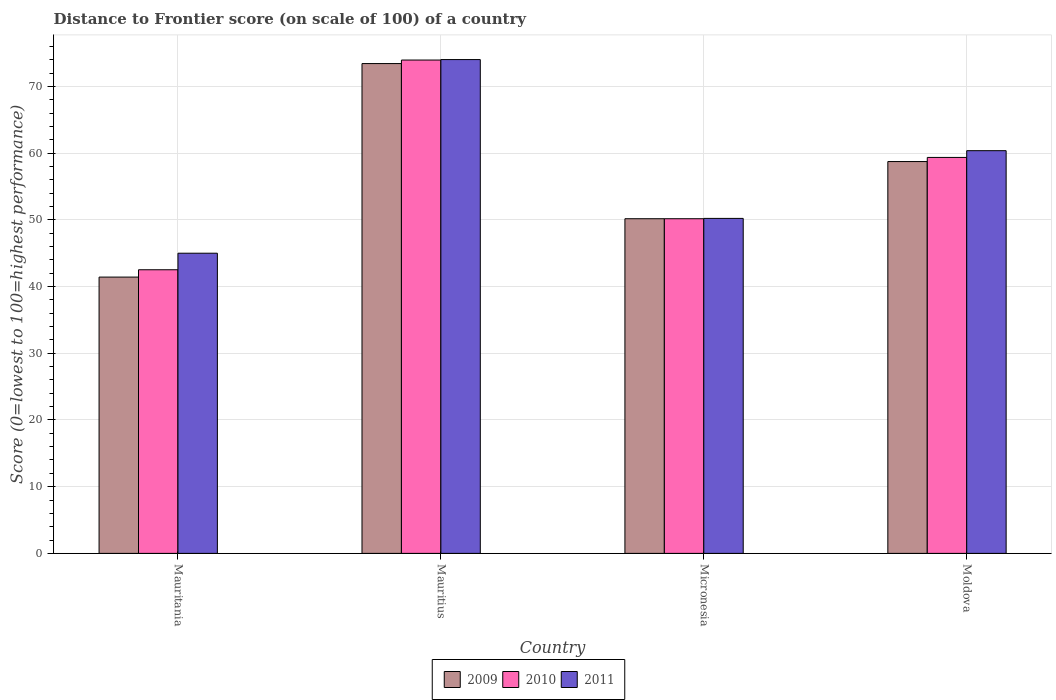How many different coloured bars are there?
Your answer should be very brief. 3. Are the number of bars per tick equal to the number of legend labels?
Give a very brief answer. Yes. Are the number of bars on each tick of the X-axis equal?
Provide a succinct answer. Yes. How many bars are there on the 3rd tick from the right?
Offer a very short reply. 3. What is the label of the 1st group of bars from the left?
Offer a terse response. Mauritania. In how many cases, is the number of bars for a given country not equal to the number of legend labels?
Your response must be concise. 0. What is the distance to frontier score of in 2010 in Mauritania?
Ensure brevity in your answer.  42.52. Across all countries, what is the maximum distance to frontier score of in 2011?
Your response must be concise. 74.03. Across all countries, what is the minimum distance to frontier score of in 2011?
Provide a short and direct response. 45. In which country was the distance to frontier score of in 2010 maximum?
Make the answer very short. Mauritius. In which country was the distance to frontier score of in 2011 minimum?
Your answer should be very brief. Mauritania. What is the total distance to frontier score of in 2009 in the graph?
Provide a short and direct response. 223.76. What is the difference between the distance to frontier score of in 2010 in Micronesia and that in Moldova?
Ensure brevity in your answer.  -9.19. What is the difference between the distance to frontier score of in 2011 in Mauritius and the distance to frontier score of in 2009 in Moldova?
Your answer should be very brief. 15.29. What is the average distance to frontier score of in 2011 per country?
Provide a short and direct response. 57.41. What is the difference between the distance to frontier score of of/in 2009 and distance to frontier score of of/in 2010 in Moldova?
Give a very brief answer. -0.62. What is the ratio of the distance to frontier score of in 2009 in Mauritius to that in Moldova?
Make the answer very short. 1.25. Is the distance to frontier score of in 2010 in Mauritania less than that in Mauritius?
Ensure brevity in your answer.  Yes. What is the difference between the highest and the second highest distance to frontier score of in 2010?
Make the answer very short. 23.79. What is the difference between the highest and the lowest distance to frontier score of in 2010?
Make the answer very short. 31.44. Is the sum of the distance to frontier score of in 2011 in Mauritius and Moldova greater than the maximum distance to frontier score of in 2009 across all countries?
Make the answer very short. Yes. What does the 1st bar from the left in Micronesia represents?
Offer a very short reply. 2009. What does the 3rd bar from the right in Mauritania represents?
Keep it short and to the point. 2009. Is it the case that in every country, the sum of the distance to frontier score of in 2009 and distance to frontier score of in 2010 is greater than the distance to frontier score of in 2011?
Your answer should be compact. Yes. How many countries are there in the graph?
Give a very brief answer. 4. Are the values on the major ticks of Y-axis written in scientific E-notation?
Offer a terse response. No. How are the legend labels stacked?
Provide a short and direct response. Horizontal. What is the title of the graph?
Your answer should be very brief. Distance to Frontier score (on scale of 100) of a country. Does "1965" appear as one of the legend labels in the graph?
Provide a short and direct response. No. What is the label or title of the Y-axis?
Ensure brevity in your answer.  Score (0=lowest to 100=highest performance). What is the Score (0=lowest to 100=highest performance) of 2009 in Mauritania?
Your answer should be compact. 41.42. What is the Score (0=lowest to 100=highest performance) in 2010 in Mauritania?
Provide a short and direct response. 42.52. What is the Score (0=lowest to 100=highest performance) in 2009 in Mauritius?
Keep it short and to the point. 73.43. What is the Score (0=lowest to 100=highest performance) of 2010 in Mauritius?
Provide a short and direct response. 73.96. What is the Score (0=lowest to 100=highest performance) in 2011 in Mauritius?
Provide a short and direct response. 74.03. What is the Score (0=lowest to 100=highest performance) of 2009 in Micronesia?
Provide a succinct answer. 50.17. What is the Score (0=lowest to 100=highest performance) of 2010 in Micronesia?
Ensure brevity in your answer.  50.17. What is the Score (0=lowest to 100=highest performance) of 2011 in Micronesia?
Give a very brief answer. 50.22. What is the Score (0=lowest to 100=highest performance) of 2009 in Moldova?
Ensure brevity in your answer.  58.74. What is the Score (0=lowest to 100=highest performance) in 2010 in Moldova?
Offer a very short reply. 59.36. What is the Score (0=lowest to 100=highest performance) of 2011 in Moldova?
Your answer should be very brief. 60.37. Across all countries, what is the maximum Score (0=lowest to 100=highest performance) in 2009?
Give a very brief answer. 73.43. Across all countries, what is the maximum Score (0=lowest to 100=highest performance) in 2010?
Keep it short and to the point. 73.96. Across all countries, what is the maximum Score (0=lowest to 100=highest performance) in 2011?
Make the answer very short. 74.03. Across all countries, what is the minimum Score (0=lowest to 100=highest performance) of 2009?
Provide a succinct answer. 41.42. Across all countries, what is the minimum Score (0=lowest to 100=highest performance) in 2010?
Ensure brevity in your answer.  42.52. Across all countries, what is the minimum Score (0=lowest to 100=highest performance) of 2011?
Keep it short and to the point. 45. What is the total Score (0=lowest to 100=highest performance) in 2009 in the graph?
Keep it short and to the point. 223.76. What is the total Score (0=lowest to 100=highest performance) of 2010 in the graph?
Your answer should be very brief. 226.01. What is the total Score (0=lowest to 100=highest performance) in 2011 in the graph?
Your answer should be compact. 229.62. What is the difference between the Score (0=lowest to 100=highest performance) of 2009 in Mauritania and that in Mauritius?
Offer a very short reply. -32.01. What is the difference between the Score (0=lowest to 100=highest performance) of 2010 in Mauritania and that in Mauritius?
Provide a short and direct response. -31.44. What is the difference between the Score (0=lowest to 100=highest performance) in 2011 in Mauritania and that in Mauritius?
Make the answer very short. -29.03. What is the difference between the Score (0=lowest to 100=highest performance) in 2009 in Mauritania and that in Micronesia?
Provide a succinct answer. -8.75. What is the difference between the Score (0=lowest to 100=highest performance) in 2010 in Mauritania and that in Micronesia?
Your response must be concise. -7.65. What is the difference between the Score (0=lowest to 100=highest performance) of 2011 in Mauritania and that in Micronesia?
Your response must be concise. -5.22. What is the difference between the Score (0=lowest to 100=highest performance) of 2009 in Mauritania and that in Moldova?
Ensure brevity in your answer.  -17.32. What is the difference between the Score (0=lowest to 100=highest performance) of 2010 in Mauritania and that in Moldova?
Your answer should be compact. -16.84. What is the difference between the Score (0=lowest to 100=highest performance) in 2011 in Mauritania and that in Moldova?
Provide a succinct answer. -15.37. What is the difference between the Score (0=lowest to 100=highest performance) of 2009 in Mauritius and that in Micronesia?
Your response must be concise. 23.26. What is the difference between the Score (0=lowest to 100=highest performance) in 2010 in Mauritius and that in Micronesia?
Offer a terse response. 23.79. What is the difference between the Score (0=lowest to 100=highest performance) in 2011 in Mauritius and that in Micronesia?
Provide a short and direct response. 23.81. What is the difference between the Score (0=lowest to 100=highest performance) in 2009 in Mauritius and that in Moldova?
Provide a succinct answer. 14.69. What is the difference between the Score (0=lowest to 100=highest performance) of 2010 in Mauritius and that in Moldova?
Your answer should be compact. 14.6. What is the difference between the Score (0=lowest to 100=highest performance) of 2011 in Mauritius and that in Moldova?
Your answer should be compact. 13.66. What is the difference between the Score (0=lowest to 100=highest performance) in 2009 in Micronesia and that in Moldova?
Ensure brevity in your answer.  -8.57. What is the difference between the Score (0=lowest to 100=highest performance) of 2010 in Micronesia and that in Moldova?
Offer a terse response. -9.19. What is the difference between the Score (0=lowest to 100=highest performance) in 2011 in Micronesia and that in Moldova?
Offer a very short reply. -10.15. What is the difference between the Score (0=lowest to 100=highest performance) in 2009 in Mauritania and the Score (0=lowest to 100=highest performance) in 2010 in Mauritius?
Your answer should be very brief. -32.54. What is the difference between the Score (0=lowest to 100=highest performance) of 2009 in Mauritania and the Score (0=lowest to 100=highest performance) of 2011 in Mauritius?
Ensure brevity in your answer.  -32.61. What is the difference between the Score (0=lowest to 100=highest performance) in 2010 in Mauritania and the Score (0=lowest to 100=highest performance) in 2011 in Mauritius?
Your response must be concise. -31.51. What is the difference between the Score (0=lowest to 100=highest performance) in 2009 in Mauritania and the Score (0=lowest to 100=highest performance) in 2010 in Micronesia?
Keep it short and to the point. -8.75. What is the difference between the Score (0=lowest to 100=highest performance) in 2009 in Mauritania and the Score (0=lowest to 100=highest performance) in 2010 in Moldova?
Make the answer very short. -17.94. What is the difference between the Score (0=lowest to 100=highest performance) in 2009 in Mauritania and the Score (0=lowest to 100=highest performance) in 2011 in Moldova?
Give a very brief answer. -18.95. What is the difference between the Score (0=lowest to 100=highest performance) of 2010 in Mauritania and the Score (0=lowest to 100=highest performance) of 2011 in Moldova?
Provide a short and direct response. -17.85. What is the difference between the Score (0=lowest to 100=highest performance) of 2009 in Mauritius and the Score (0=lowest to 100=highest performance) of 2010 in Micronesia?
Make the answer very short. 23.26. What is the difference between the Score (0=lowest to 100=highest performance) of 2009 in Mauritius and the Score (0=lowest to 100=highest performance) of 2011 in Micronesia?
Give a very brief answer. 23.21. What is the difference between the Score (0=lowest to 100=highest performance) in 2010 in Mauritius and the Score (0=lowest to 100=highest performance) in 2011 in Micronesia?
Provide a succinct answer. 23.74. What is the difference between the Score (0=lowest to 100=highest performance) of 2009 in Mauritius and the Score (0=lowest to 100=highest performance) of 2010 in Moldova?
Provide a succinct answer. 14.07. What is the difference between the Score (0=lowest to 100=highest performance) in 2009 in Mauritius and the Score (0=lowest to 100=highest performance) in 2011 in Moldova?
Your answer should be very brief. 13.06. What is the difference between the Score (0=lowest to 100=highest performance) in 2010 in Mauritius and the Score (0=lowest to 100=highest performance) in 2011 in Moldova?
Offer a terse response. 13.59. What is the difference between the Score (0=lowest to 100=highest performance) in 2009 in Micronesia and the Score (0=lowest to 100=highest performance) in 2010 in Moldova?
Offer a very short reply. -9.19. What is the difference between the Score (0=lowest to 100=highest performance) in 2009 in Micronesia and the Score (0=lowest to 100=highest performance) in 2011 in Moldova?
Give a very brief answer. -10.2. What is the difference between the Score (0=lowest to 100=highest performance) in 2010 in Micronesia and the Score (0=lowest to 100=highest performance) in 2011 in Moldova?
Offer a terse response. -10.2. What is the average Score (0=lowest to 100=highest performance) of 2009 per country?
Provide a short and direct response. 55.94. What is the average Score (0=lowest to 100=highest performance) in 2010 per country?
Keep it short and to the point. 56.5. What is the average Score (0=lowest to 100=highest performance) in 2011 per country?
Give a very brief answer. 57.41. What is the difference between the Score (0=lowest to 100=highest performance) in 2009 and Score (0=lowest to 100=highest performance) in 2010 in Mauritania?
Keep it short and to the point. -1.1. What is the difference between the Score (0=lowest to 100=highest performance) in 2009 and Score (0=lowest to 100=highest performance) in 2011 in Mauritania?
Provide a succinct answer. -3.58. What is the difference between the Score (0=lowest to 100=highest performance) of 2010 and Score (0=lowest to 100=highest performance) of 2011 in Mauritania?
Your response must be concise. -2.48. What is the difference between the Score (0=lowest to 100=highest performance) in 2009 and Score (0=lowest to 100=highest performance) in 2010 in Mauritius?
Your answer should be very brief. -0.53. What is the difference between the Score (0=lowest to 100=highest performance) in 2009 and Score (0=lowest to 100=highest performance) in 2011 in Mauritius?
Ensure brevity in your answer.  -0.6. What is the difference between the Score (0=lowest to 100=highest performance) in 2010 and Score (0=lowest to 100=highest performance) in 2011 in Mauritius?
Provide a short and direct response. -0.07. What is the difference between the Score (0=lowest to 100=highest performance) of 2010 and Score (0=lowest to 100=highest performance) of 2011 in Micronesia?
Make the answer very short. -0.05. What is the difference between the Score (0=lowest to 100=highest performance) in 2009 and Score (0=lowest to 100=highest performance) in 2010 in Moldova?
Provide a succinct answer. -0.62. What is the difference between the Score (0=lowest to 100=highest performance) of 2009 and Score (0=lowest to 100=highest performance) of 2011 in Moldova?
Offer a terse response. -1.63. What is the difference between the Score (0=lowest to 100=highest performance) of 2010 and Score (0=lowest to 100=highest performance) of 2011 in Moldova?
Ensure brevity in your answer.  -1.01. What is the ratio of the Score (0=lowest to 100=highest performance) in 2009 in Mauritania to that in Mauritius?
Your answer should be compact. 0.56. What is the ratio of the Score (0=lowest to 100=highest performance) in 2010 in Mauritania to that in Mauritius?
Your answer should be compact. 0.57. What is the ratio of the Score (0=lowest to 100=highest performance) in 2011 in Mauritania to that in Mauritius?
Your answer should be compact. 0.61. What is the ratio of the Score (0=lowest to 100=highest performance) in 2009 in Mauritania to that in Micronesia?
Keep it short and to the point. 0.83. What is the ratio of the Score (0=lowest to 100=highest performance) of 2010 in Mauritania to that in Micronesia?
Keep it short and to the point. 0.85. What is the ratio of the Score (0=lowest to 100=highest performance) of 2011 in Mauritania to that in Micronesia?
Make the answer very short. 0.9. What is the ratio of the Score (0=lowest to 100=highest performance) in 2009 in Mauritania to that in Moldova?
Give a very brief answer. 0.71. What is the ratio of the Score (0=lowest to 100=highest performance) of 2010 in Mauritania to that in Moldova?
Your response must be concise. 0.72. What is the ratio of the Score (0=lowest to 100=highest performance) of 2011 in Mauritania to that in Moldova?
Offer a very short reply. 0.75. What is the ratio of the Score (0=lowest to 100=highest performance) of 2009 in Mauritius to that in Micronesia?
Ensure brevity in your answer.  1.46. What is the ratio of the Score (0=lowest to 100=highest performance) in 2010 in Mauritius to that in Micronesia?
Offer a terse response. 1.47. What is the ratio of the Score (0=lowest to 100=highest performance) in 2011 in Mauritius to that in Micronesia?
Offer a terse response. 1.47. What is the ratio of the Score (0=lowest to 100=highest performance) in 2009 in Mauritius to that in Moldova?
Your answer should be very brief. 1.25. What is the ratio of the Score (0=lowest to 100=highest performance) in 2010 in Mauritius to that in Moldova?
Make the answer very short. 1.25. What is the ratio of the Score (0=lowest to 100=highest performance) in 2011 in Mauritius to that in Moldova?
Provide a short and direct response. 1.23. What is the ratio of the Score (0=lowest to 100=highest performance) in 2009 in Micronesia to that in Moldova?
Offer a very short reply. 0.85. What is the ratio of the Score (0=lowest to 100=highest performance) of 2010 in Micronesia to that in Moldova?
Provide a succinct answer. 0.85. What is the ratio of the Score (0=lowest to 100=highest performance) of 2011 in Micronesia to that in Moldova?
Ensure brevity in your answer.  0.83. What is the difference between the highest and the second highest Score (0=lowest to 100=highest performance) of 2009?
Make the answer very short. 14.69. What is the difference between the highest and the second highest Score (0=lowest to 100=highest performance) in 2011?
Your answer should be very brief. 13.66. What is the difference between the highest and the lowest Score (0=lowest to 100=highest performance) in 2009?
Provide a succinct answer. 32.01. What is the difference between the highest and the lowest Score (0=lowest to 100=highest performance) in 2010?
Keep it short and to the point. 31.44. What is the difference between the highest and the lowest Score (0=lowest to 100=highest performance) in 2011?
Provide a succinct answer. 29.03. 